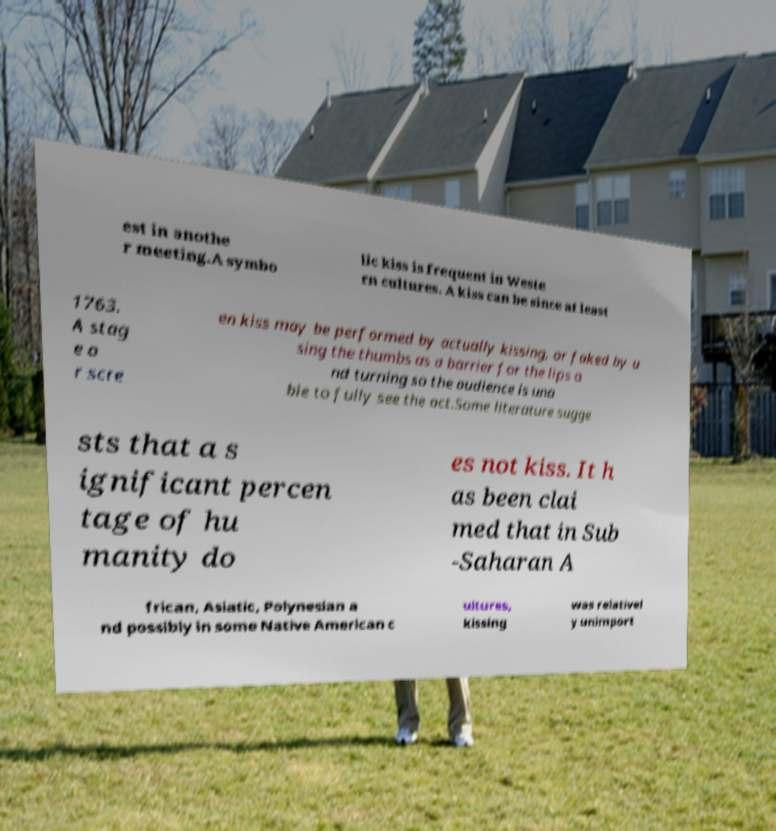Please identify and transcribe the text found in this image. est in anothe r meeting.A symbo lic kiss is frequent in Weste rn cultures. A kiss can be since at least 1763. A stag e o r scre en kiss may be performed by actually kissing, or faked by u sing the thumbs as a barrier for the lips a nd turning so the audience is una ble to fully see the act.Some literature sugge sts that a s ignificant percen tage of hu manity do es not kiss. It h as been clai med that in Sub -Saharan A frican, Asiatic, Polynesian a nd possibly in some Native American c ultures, kissing was relativel y unimport 